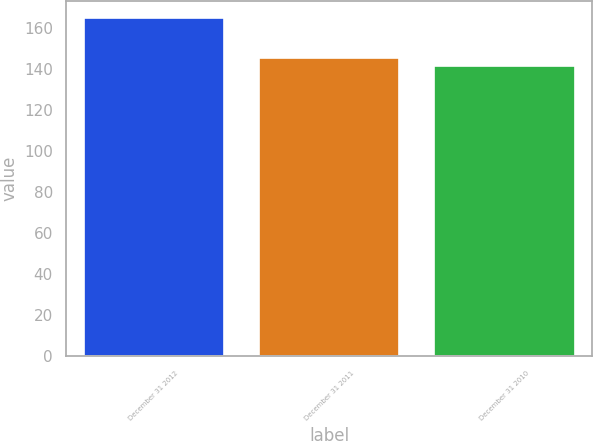Convert chart. <chart><loc_0><loc_0><loc_500><loc_500><bar_chart><fcel>December 31 2012<fcel>December 31 2011<fcel>December 31 2010<nl><fcel>165<fcel>145.4<fcel>141.4<nl></chart> 